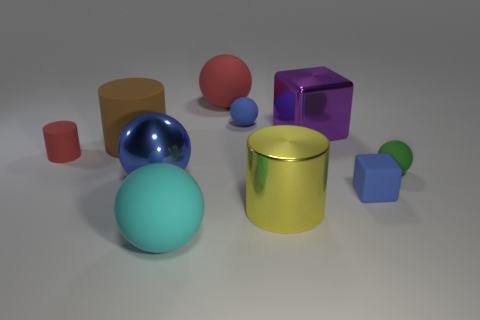There is a blue rubber object that is in front of the brown cylinder; is it the same shape as the object that is in front of the big yellow cylinder?
Ensure brevity in your answer.  No. Are there any blue metal balls?
Ensure brevity in your answer.  Yes. There is a metallic ball that is the same size as the cyan matte ball; what is its color?
Provide a short and direct response. Blue. How many other big purple objects have the same shape as the large purple metallic object?
Your answer should be very brief. 0. Do the small thing left of the big red rubber ball and the big purple object have the same material?
Your response must be concise. No. How many cubes are either cyan matte things or yellow matte things?
Give a very brief answer. 0. There is a big red object that is behind the tiny blue object left of the blue rubber object in front of the big purple cube; what is its shape?
Your response must be concise. Sphere. The big thing that is the same color as the tiny rubber cylinder is what shape?
Your answer should be very brief. Sphere. What number of cyan things have the same size as the shiny cylinder?
Your answer should be very brief. 1. Are there any cylinders behind the blue thing that is left of the cyan object?
Give a very brief answer. Yes. 